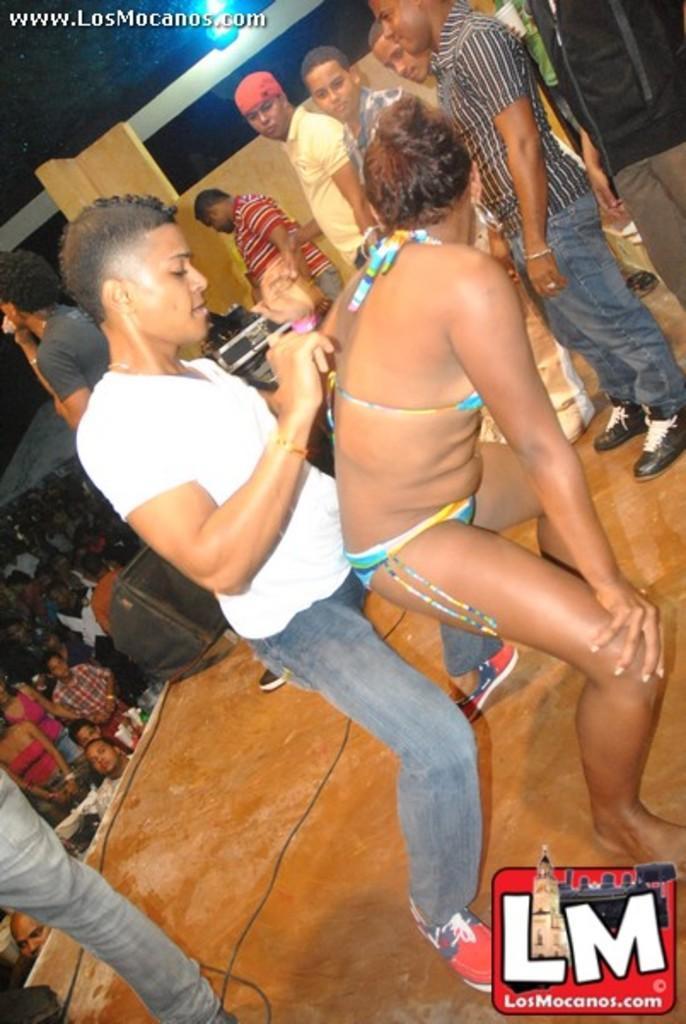How would you summarize this image in a sentence or two? In this image there are two people dancing, beside them there are a few people standing and watching them, in the background of the image there is a speaker, behind the speaker there are a few people. 